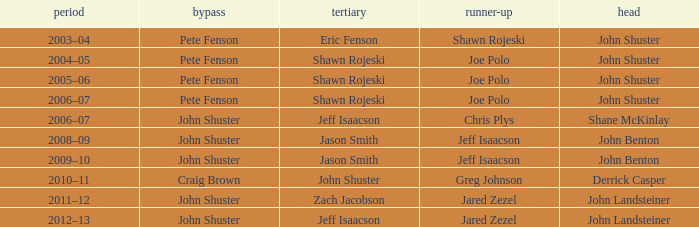Could you parse the entire table as a dict? {'header': ['period', 'bypass', 'tertiary', 'runner-up', 'head'], 'rows': [['2003–04', 'Pete Fenson', 'Eric Fenson', 'Shawn Rojeski', 'John Shuster'], ['2004–05', 'Pete Fenson', 'Shawn Rojeski', 'Joe Polo', 'John Shuster'], ['2005–06', 'Pete Fenson', 'Shawn Rojeski', 'Joe Polo', 'John Shuster'], ['2006–07', 'Pete Fenson', 'Shawn Rojeski', 'Joe Polo', 'John Shuster'], ['2006–07', 'John Shuster', 'Jeff Isaacson', 'Chris Plys', 'Shane McKinlay'], ['2008–09', 'John Shuster', 'Jason Smith', 'Jeff Isaacson', 'John Benton'], ['2009–10', 'John Shuster', 'Jason Smith', 'Jeff Isaacson', 'John Benton'], ['2010–11', 'Craig Brown', 'John Shuster', 'Greg Johnson', 'Derrick Casper'], ['2011–12', 'John Shuster', 'Zach Jacobson', 'Jared Zezel', 'John Landsteiner'], ['2012–13', 'John Shuster', 'Jeff Isaacson', 'Jared Zezel', 'John Landsteiner']]} Who was the lead with John Shuster as skip in the season of 2009–10? John Benton. 